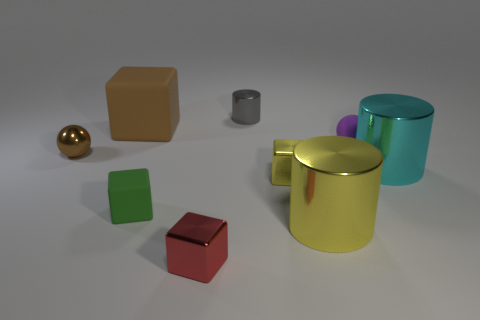Subtract all big rubber cubes. How many cubes are left? 3 Subtract 1 cylinders. How many cylinders are left? 2 Subtract all yellow blocks. How many blocks are left? 3 Subtract all purple blocks. Subtract all brown cylinders. How many blocks are left? 4 Subtract all blocks. How many objects are left? 5 Add 8 yellow cylinders. How many yellow cylinders are left? 9 Add 8 small gray cylinders. How many small gray cylinders exist? 9 Subtract 0 blue balls. How many objects are left? 9 Subtract all small purple balls. Subtract all cyan blocks. How many objects are left? 8 